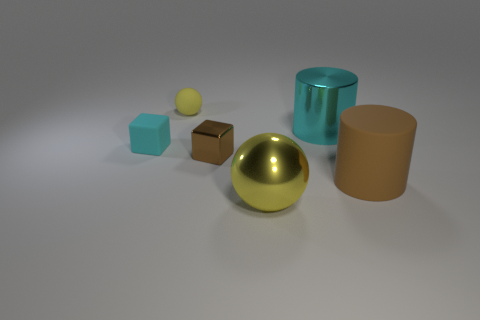Add 2 big brown cylinders. How many objects exist? 8 Subtract all balls. How many objects are left? 4 Subtract all small gray shiny things. Subtract all cyan metal cylinders. How many objects are left? 5 Add 3 yellow matte spheres. How many yellow matte spheres are left? 4 Add 6 red rubber things. How many red rubber things exist? 6 Subtract 0 gray cylinders. How many objects are left? 6 